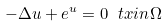<formula> <loc_0><loc_0><loc_500><loc_500>- \Delta u + e ^ { u } = 0 \ t x { i n } \Omega</formula> 